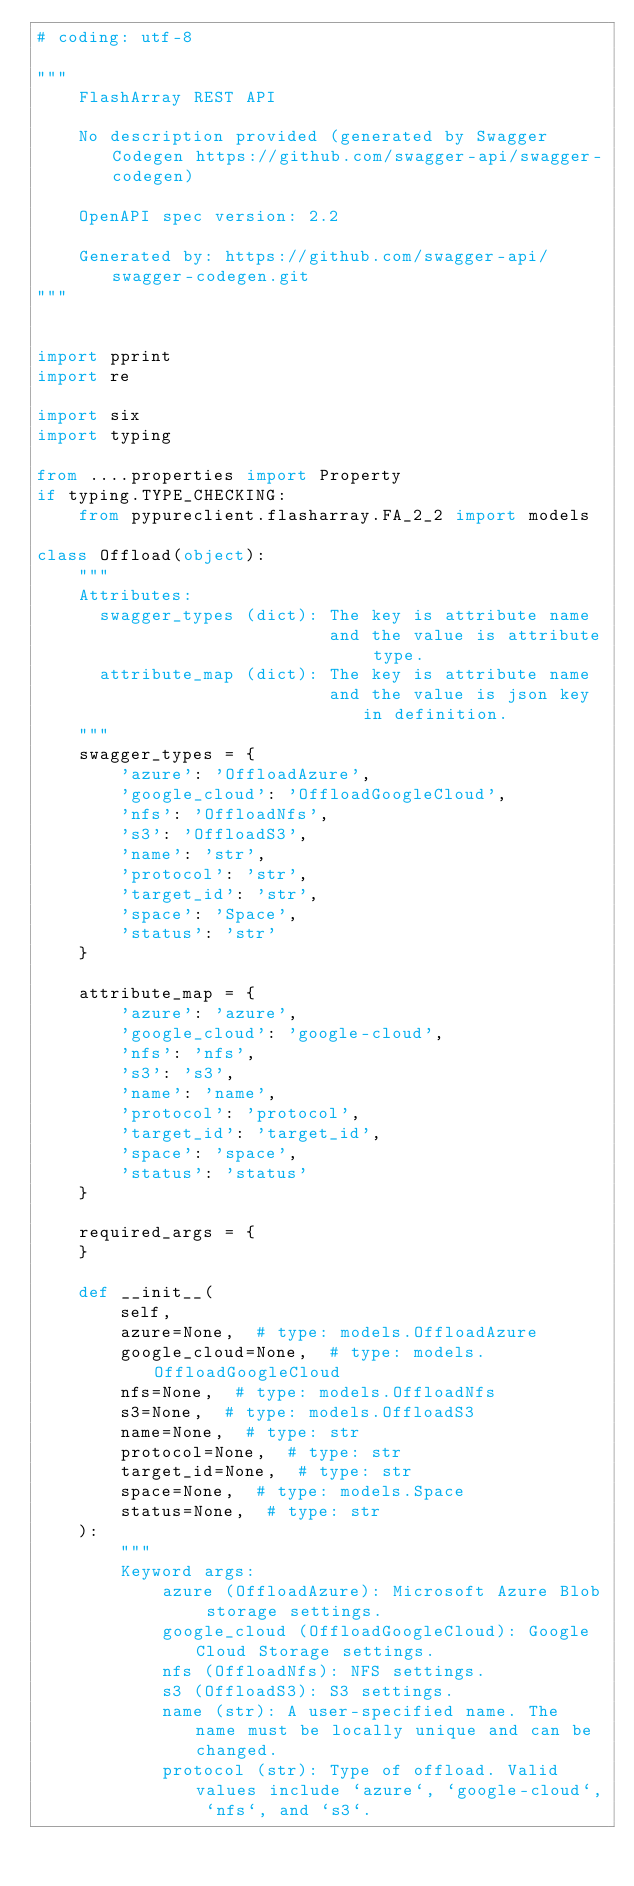Convert code to text. <code><loc_0><loc_0><loc_500><loc_500><_Python_># coding: utf-8

"""
    FlashArray REST API

    No description provided (generated by Swagger Codegen https://github.com/swagger-api/swagger-codegen)

    OpenAPI spec version: 2.2
    
    Generated by: https://github.com/swagger-api/swagger-codegen.git
"""


import pprint
import re

import six
import typing

from ....properties import Property
if typing.TYPE_CHECKING:
    from pypureclient.flasharray.FA_2_2 import models

class Offload(object):
    """
    Attributes:
      swagger_types (dict): The key is attribute name
                            and the value is attribute type.
      attribute_map (dict): The key is attribute name
                            and the value is json key in definition.
    """
    swagger_types = {
        'azure': 'OffloadAzure',
        'google_cloud': 'OffloadGoogleCloud',
        'nfs': 'OffloadNfs',
        's3': 'OffloadS3',
        'name': 'str',
        'protocol': 'str',
        'target_id': 'str',
        'space': 'Space',
        'status': 'str'
    }

    attribute_map = {
        'azure': 'azure',
        'google_cloud': 'google-cloud',
        'nfs': 'nfs',
        's3': 's3',
        'name': 'name',
        'protocol': 'protocol',
        'target_id': 'target_id',
        'space': 'space',
        'status': 'status'
    }

    required_args = {
    }

    def __init__(
        self,
        azure=None,  # type: models.OffloadAzure
        google_cloud=None,  # type: models.OffloadGoogleCloud
        nfs=None,  # type: models.OffloadNfs
        s3=None,  # type: models.OffloadS3
        name=None,  # type: str
        protocol=None,  # type: str
        target_id=None,  # type: str
        space=None,  # type: models.Space
        status=None,  # type: str
    ):
        """
        Keyword args:
            azure (OffloadAzure): Microsoft Azure Blob storage settings.
            google_cloud (OffloadGoogleCloud): Google Cloud Storage settings.
            nfs (OffloadNfs): NFS settings.
            s3 (OffloadS3): S3 settings.
            name (str): A user-specified name. The name must be locally unique and can be changed.
            protocol (str): Type of offload. Valid values include `azure`, `google-cloud`, `nfs`, and `s3`.</code> 